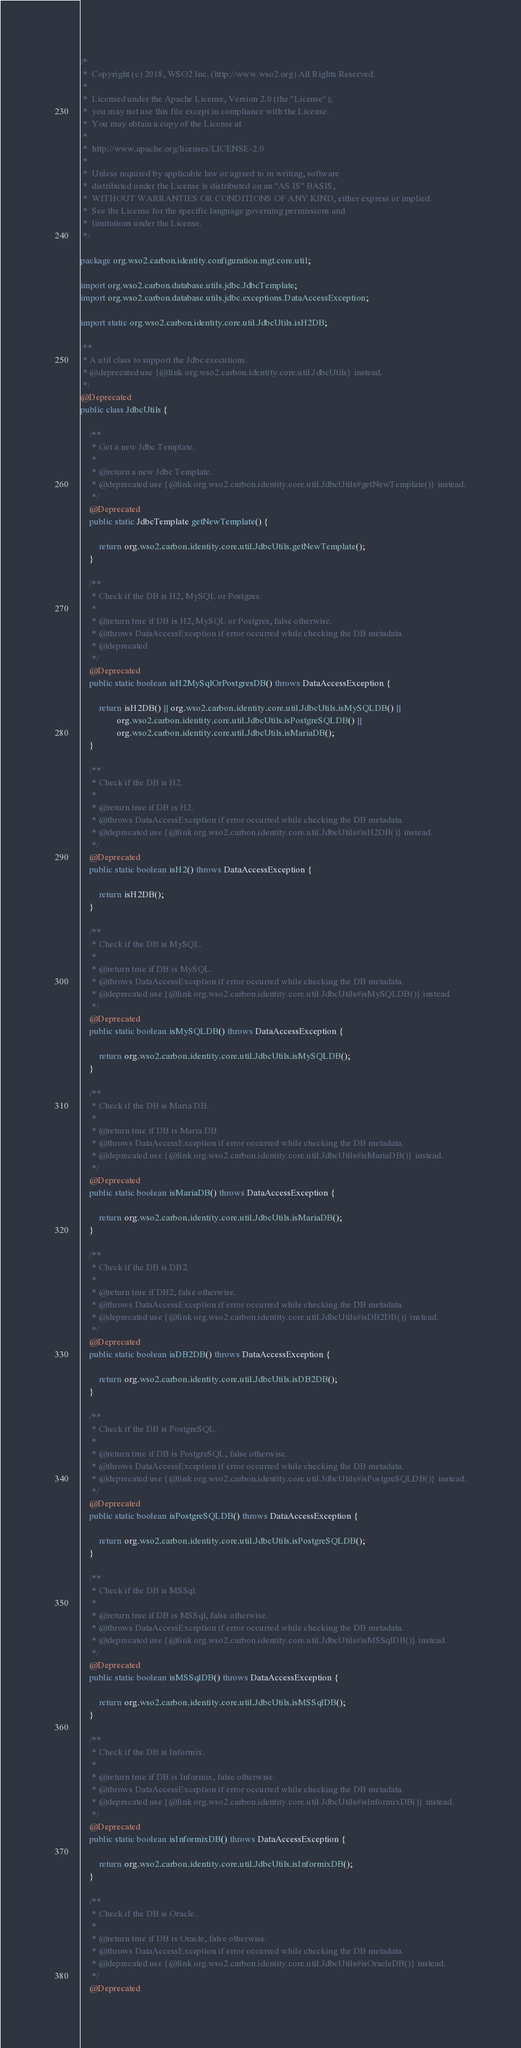<code> <loc_0><loc_0><loc_500><loc_500><_Java_>/*
 *  Copyright (c) 2018, WSO2 Inc. (http://www.wso2.org) All Rights Reserved.
 *
 *  Licensed under the Apache License, Version 2.0 (the "License");
 *  you may not use this file except in compliance with the License.
 *  You may obtain a copy of the License at
 *
 *  http://www.apache.org/licenses/LICENSE-2.0
 *
 *  Unless required by applicable law or agreed to in writing, software
 *  distributed under the License is distributed on an "AS IS" BASIS,
 *  WITHOUT WARRANTIES OR CONDITIONS OF ANY KIND, either express or implied.
 *  See the License for the specific language governing permissions and
 *  limitations under the License.
 */

package org.wso2.carbon.identity.configuration.mgt.core.util;

import org.wso2.carbon.database.utils.jdbc.JdbcTemplate;
import org.wso2.carbon.database.utils.jdbc.exceptions.DataAccessException;

import static org.wso2.carbon.identity.core.util.JdbcUtils.isH2DB;

/**
 * A util class to support the Jdbc executions.
 * @deprecated use {@link org.wso2.carbon.identity.core.util.JdbcUtils} instead.
 */
@Deprecated
public class JdbcUtils {

    /**
     * Get a new Jdbc Template.
     *
     * @return a new Jdbc Template.
     * @deprecated use {@link org.wso2.carbon.identity.core.util.JdbcUtils#getNewTemplate()} instead.
     */
    @Deprecated
    public static JdbcTemplate getNewTemplate() {

        return org.wso2.carbon.identity.core.util.JdbcUtils.getNewTemplate();
    }

    /**
     * Check if the DB is H2, MySQL or Postgres.
     *
     * @return true if DB is H2, MySQL or Postgres, false otherwise.
     * @throws DataAccessException if error occurred while checking the DB metadata.
     * @deprecated
     */
    @Deprecated
    public static boolean isH2MySqlOrPostgresDB() throws DataAccessException {

        return isH2DB() || org.wso2.carbon.identity.core.util.JdbcUtils.isMySQLDB() ||
                org.wso2.carbon.identity.core.util.JdbcUtils.isPostgreSQLDB() ||
                org.wso2.carbon.identity.core.util.JdbcUtils.isMariaDB();
    }

    /**
     * Check if the DB is H2.
     *
     * @return true if DB is H2.
     * @throws DataAccessException if error occurred while checking the DB metadata.
     * @deprecated use {@link org.wso2.carbon.identity.core.util.JdbcUtils#isH2DB()} instead.
     */
    @Deprecated
    public static boolean isH2() throws DataAccessException {

        return isH2DB();
    }

    /**
     * Check if the DB is MySQL.
     *
     * @return true if DB is MySQL.
     * @throws DataAccessException if error occurred while checking the DB metadata.
     * @deprecated use {@link org.wso2.carbon.identity.core.util.JdbcUtils#isMySQLDB()} instead.
     */
    @Deprecated
    public static boolean isMySQLDB() throws DataAccessException {

        return org.wso2.carbon.identity.core.util.JdbcUtils.isMySQLDB();
    }

    /**
     * Check if the DB is Maria DB.
     *
     * @return true if DB is Maria DB.
     * @throws DataAccessException if error occurred while checking the DB metadata.
     * @deprecated use {@link org.wso2.carbon.identity.core.util.JdbcUtils#isMariaDB()} instead.
     */
    @Deprecated
    public static boolean isMariaDB() throws DataAccessException {

        return org.wso2.carbon.identity.core.util.JdbcUtils.isMariaDB();
    }

    /**
     * Check if the DB is DB2.
     *
     * @return true if DB2, false otherwise.
     * @throws DataAccessException if error occurred while checking the DB metadata.
     * @deprecated use {@link org.wso2.carbon.identity.core.util.JdbcUtils#isDB2DB()} instead.
     */
    @Deprecated
    public static boolean isDB2DB() throws DataAccessException {

        return org.wso2.carbon.identity.core.util.JdbcUtils.isDB2DB();
    }

    /**
     * Check if the DB is PostgreSQL.
     *
     * @return true if DB is PostgreSQL, false otherwise.
     * @throws DataAccessException if error occurred while checking the DB metadata.
     * @deprecated use {@link org.wso2.carbon.identity.core.util.JdbcUtils#isPostgreSQLDB()} instead.
     */
    @Deprecated
    public static boolean isPostgreSQLDB() throws DataAccessException {

        return org.wso2.carbon.identity.core.util.JdbcUtils.isPostgreSQLDB();
    }

    /**
     * Check if the DB is MSSql.
     *
     * @return true if DB is MSSql, false otherwise.
     * @throws DataAccessException if error occurred while checking the DB metadata.
     * @deprecated use {@link org.wso2.carbon.identity.core.util.JdbcUtils#isMSSqlDB()} instead.
     */
    @Deprecated
    public static boolean isMSSqlDB() throws DataAccessException {

        return org.wso2.carbon.identity.core.util.JdbcUtils.isMSSqlDB();
    }

    /**
     * Check if the DB is Informix.
     *
     * @return true if DB is Informix, false otherwise.
     * @throws DataAccessException if error occurred while checking the DB metadata.
     * @deprecated use {@link org.wso2.carbon.identity.core.util.JdbcUtils#isInformixDB()} instead.
     */
    @Deprecated
    public static boolean isInformixDB() throws DataAccessException {

        return org.wso2.carbon.identity.core.util.JdbcUtils.isInformixDB();
    }

    /**
     * Check if the DB is Oracle.
     *
     * @return true if DB is Oracle, false otherwise.
     * @throws DataAccessException if error occurred while checking the DB metadata.
     * @deprecated use {@link org.wso2.carbon.identity.core.util.JdbcUtils#isOracleDB()} instead.
     */
    @Deprecated</code> 